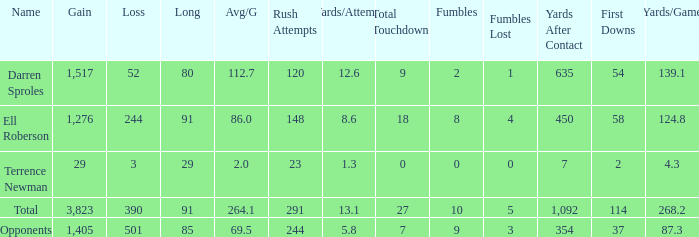What's the sum of all average yards gained when the gained yards is under 1,276 and lost more than 3 yards? None. 